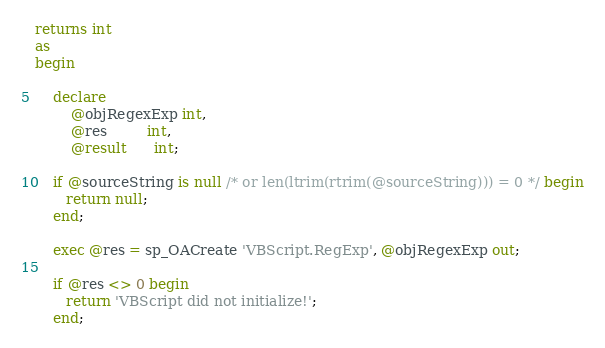<code> <loc_0><loc_0><loc_500><loc_500><_SQL_>returns int
as
begin

    declare
        @objRegexExp int, 
        @res         int,
        @result      int;

    if @sourceString is null /* or len(ltrim(rtrim(@sourceString))) = 0 */ begin
       return null;
    end;

    exec @res = sp_OACreate 'VBScript.RegExp', @objRegexExp out;

    if @res <> 0 begin
       return 'VBScript did not initialize!';
    end;
</code> 